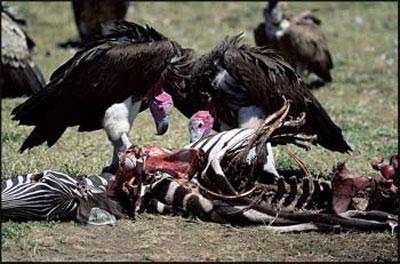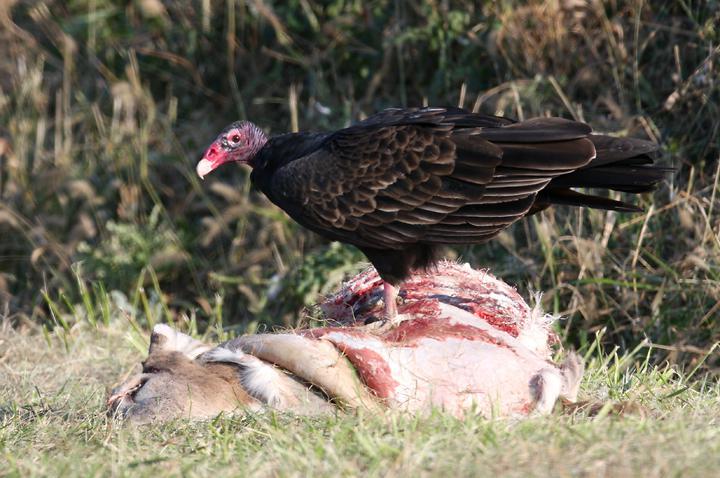The first image is the image on the left, the second image is the image on the right. Evaluate the accuracy of this statement regarding the images: "An image contains only one live vulture, which is standing next to some type of carcass, but not on top of it.". Is it true? Answer yes or no. No. The first image is the image on the left, the second image is the image on the right. For the images shown, is this caption "The right image contains no more than one large bird." true? Answer yes or no. Yes. 